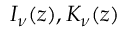Convert formula to latex. <formula><loc_0><loc_0><loc_500><loc_500>I _ { \nu } ( z ) , K _ { \nu } ( z )</formula> 